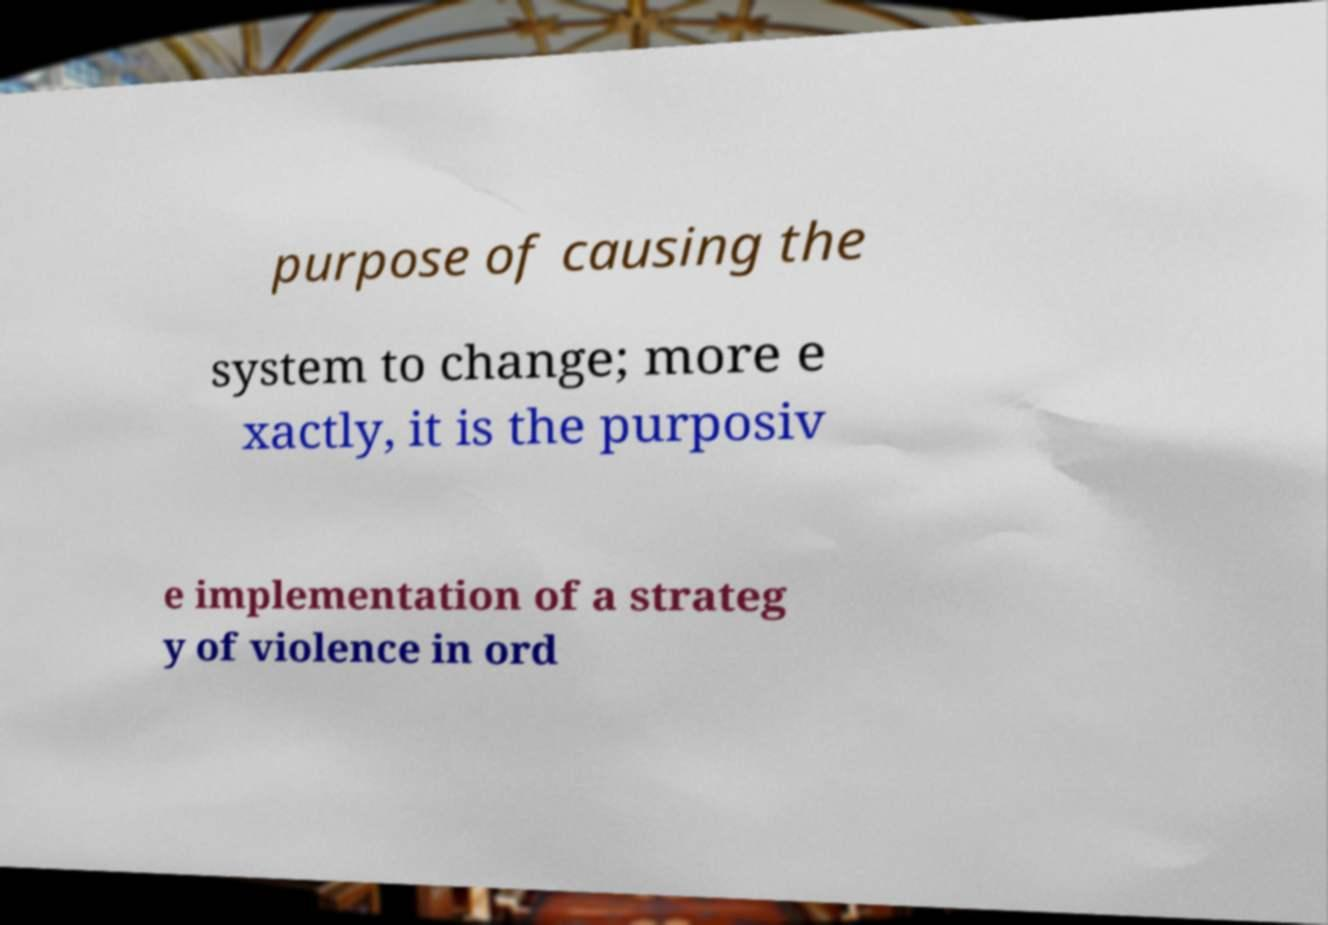There's text embedded in this image that I need extracted. Can you transcribe it verbatim? purpose of causing the system to change; more e xactly, it is the purposiv e implementation of a strateg y of violence in ord 